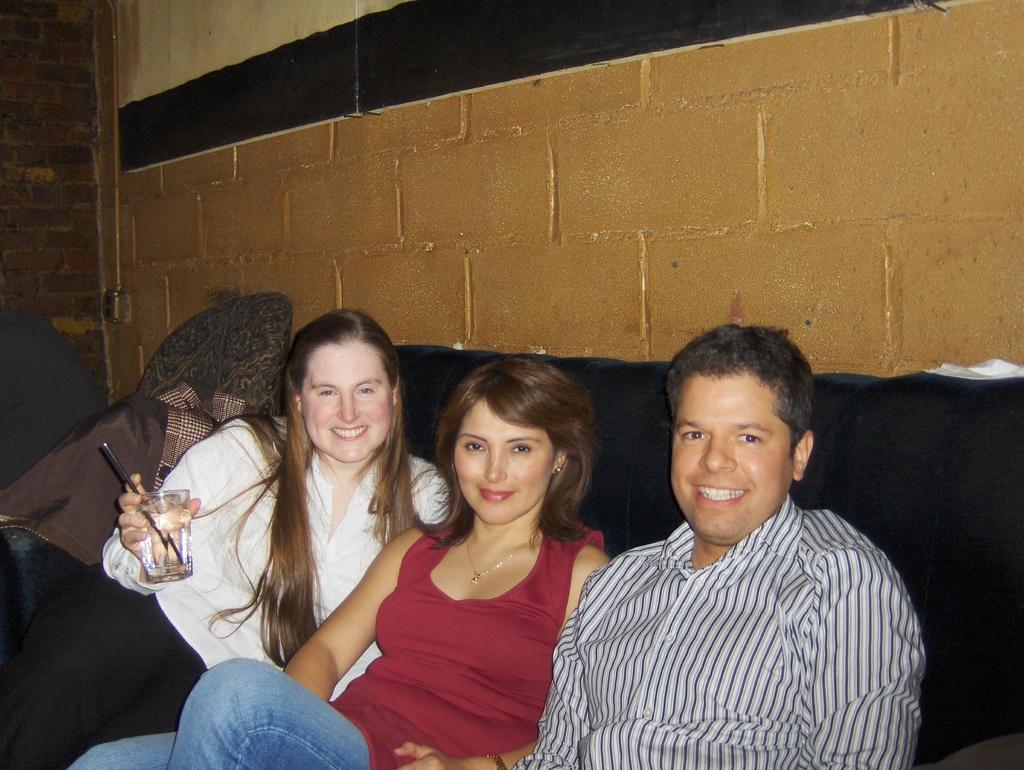How would you summarize this image in a sentence or two? There are people sitting on sofa and smiling,she is holding a glass,behind this woman we can see cloth. We can see wall. 